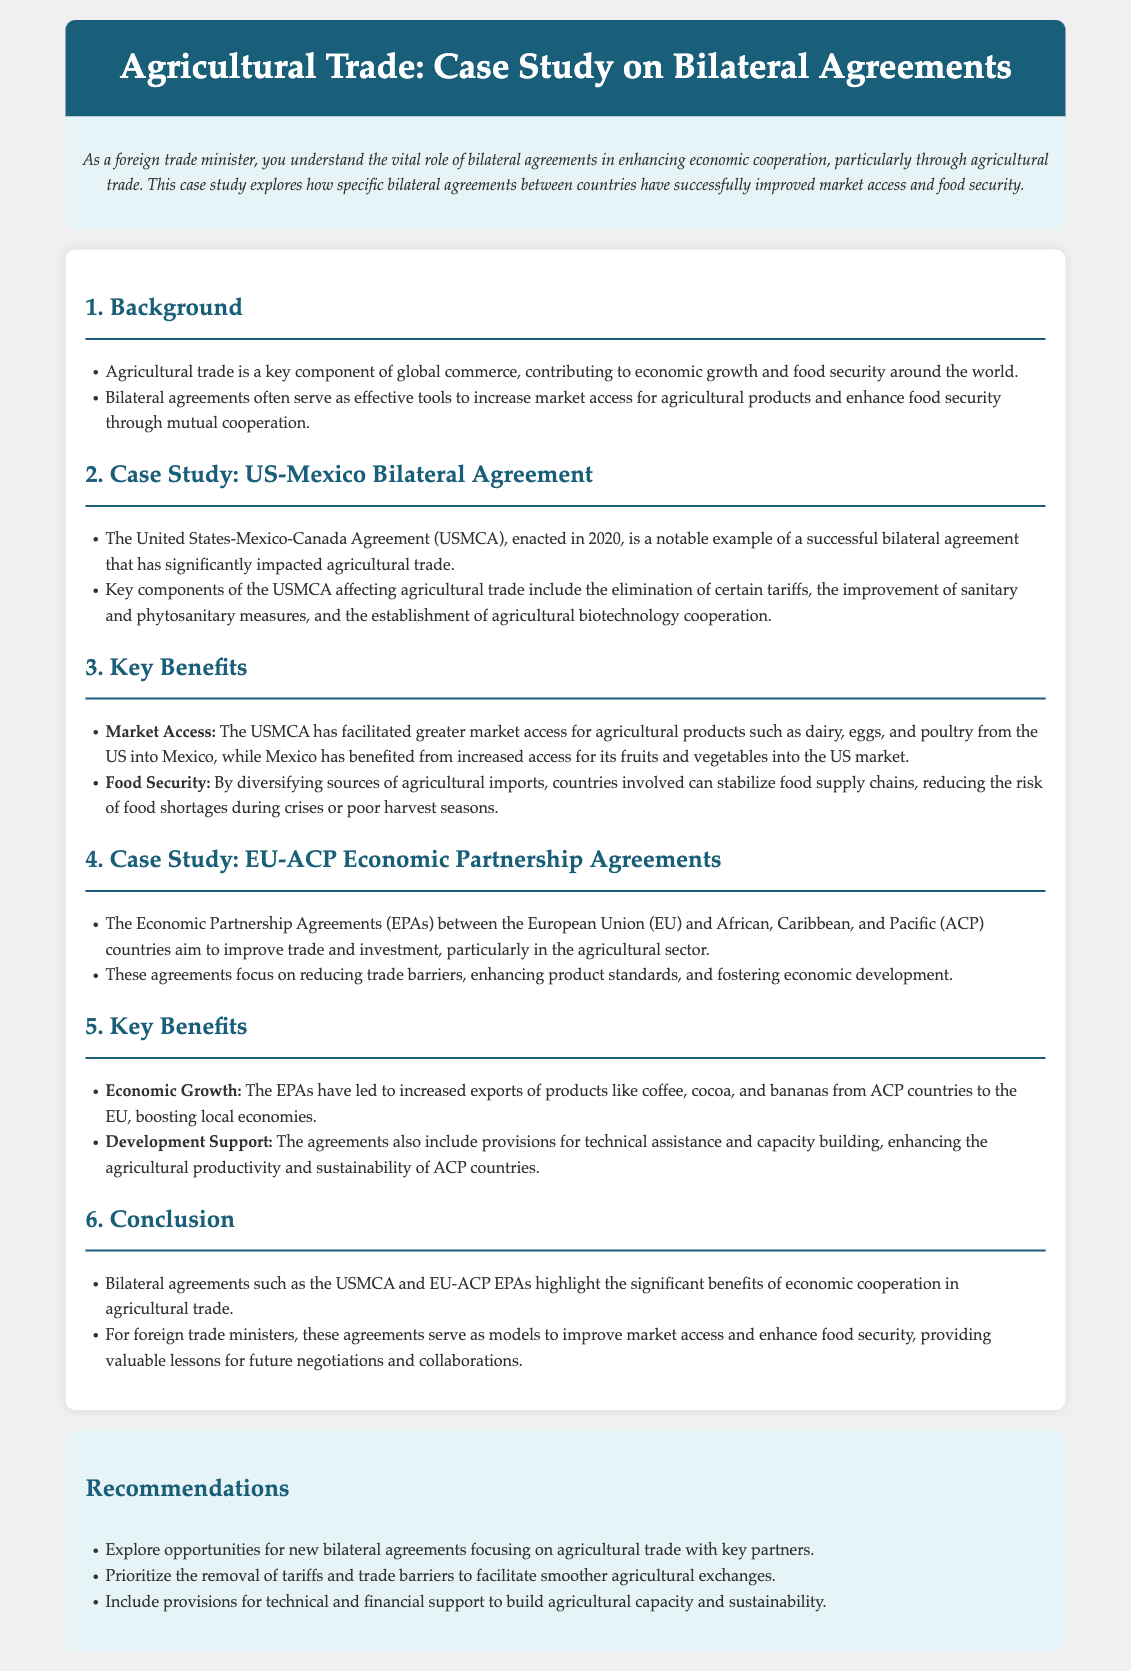What is the title of the case study? The title of the case study is presented prominently at the top of the document.
Answer: Agricultural Trade: Case Study on Bilateral Agreements When was the US-Mexico-Canada Agreement enacted? The document mentions the enactment date of the USMCA in the case study section for US-Mexico bilateral agreement.
Answer: 2020 What are two agricultural products with increased market access due to the USMCA? The key benefits section lists specific agricultural products that have improved access as a result of the USMCA.
Answer: Dairy, Eggs What is the main goal of the EU-ACP Economic Partnership Agreements? The document describes the aim of the EPAs in the section dedicated to the EU-ACP agreements.
Answer: Improve trade and investment What is a key benefit of the EU-ACP agreements for ACP countries? The document specifies benefits to ACP countries from the EPAs, especially regarding exports.
Answer: Economic Growth What kind of support is emphasized in the recommendations section? The recommendations highlight certain types of assistance that should be included in new agreements.
Answer: Technical and financial support What is one of the key components of the USMCA affecting agricultural trade? The case study discusses significant elements of the USMCA that influence agricultural trade positively.
Answer: Elimination of certain tariffs What type of measures does the USMCA improve for agricultural trade? The content refers to specific measures that are enhanced through the USMCA that affect agricultural products.
Answer: Sanitary and phytosanitary measures What are the two strategies recommended for facilitating agricultural trade? The recommendations section suggests actions to facilitate agricultural exchanges between countries.
Answer: Removal of tariffs, trade barriers 